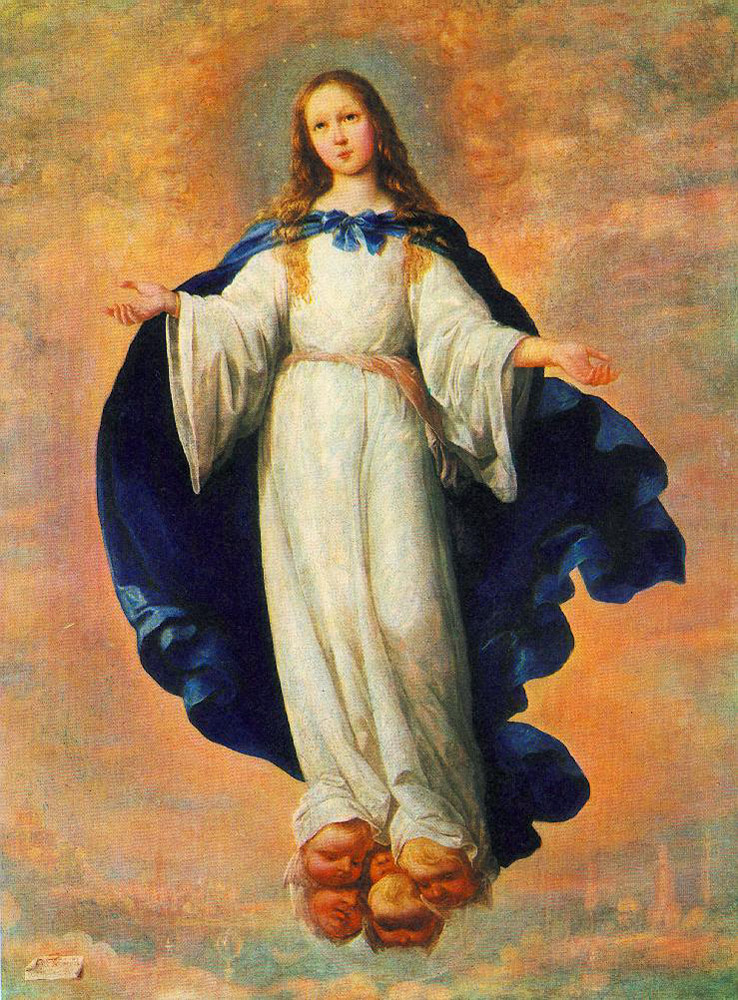What do you think is going on in this snapshot? This painting depicts a young girl floating above a cityscape with a serene and composed expression. She is dressed in a flowing white gown with a deep blue cloak, giving her a celestial or angelic appearance, which might imply she is a representation of a religious figure, possibly an angel. Her gaze invites a contemplative mood, suggesting she is overlooking the mortal world from the heavens. This image is crafted with a blend of realism and idealism, emphasizing the spiritual theme and evoking a sense of calm and protective oversight. 